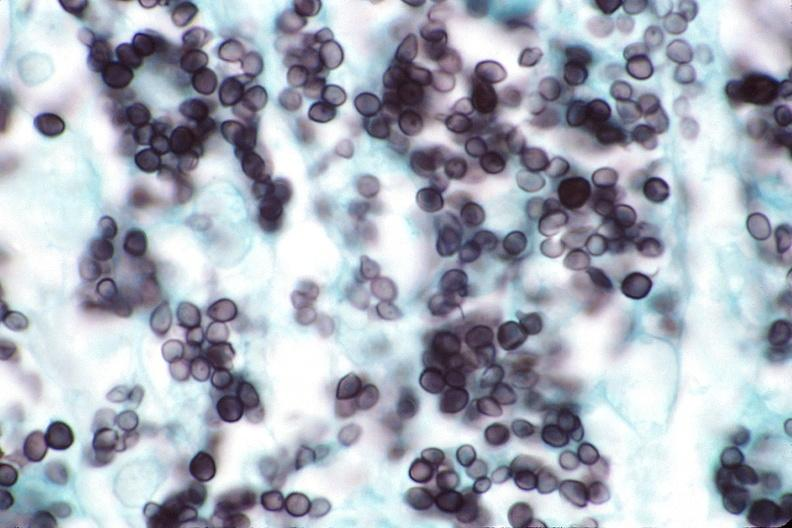what stain?
Answer the question using a single word or phrase. Silver 